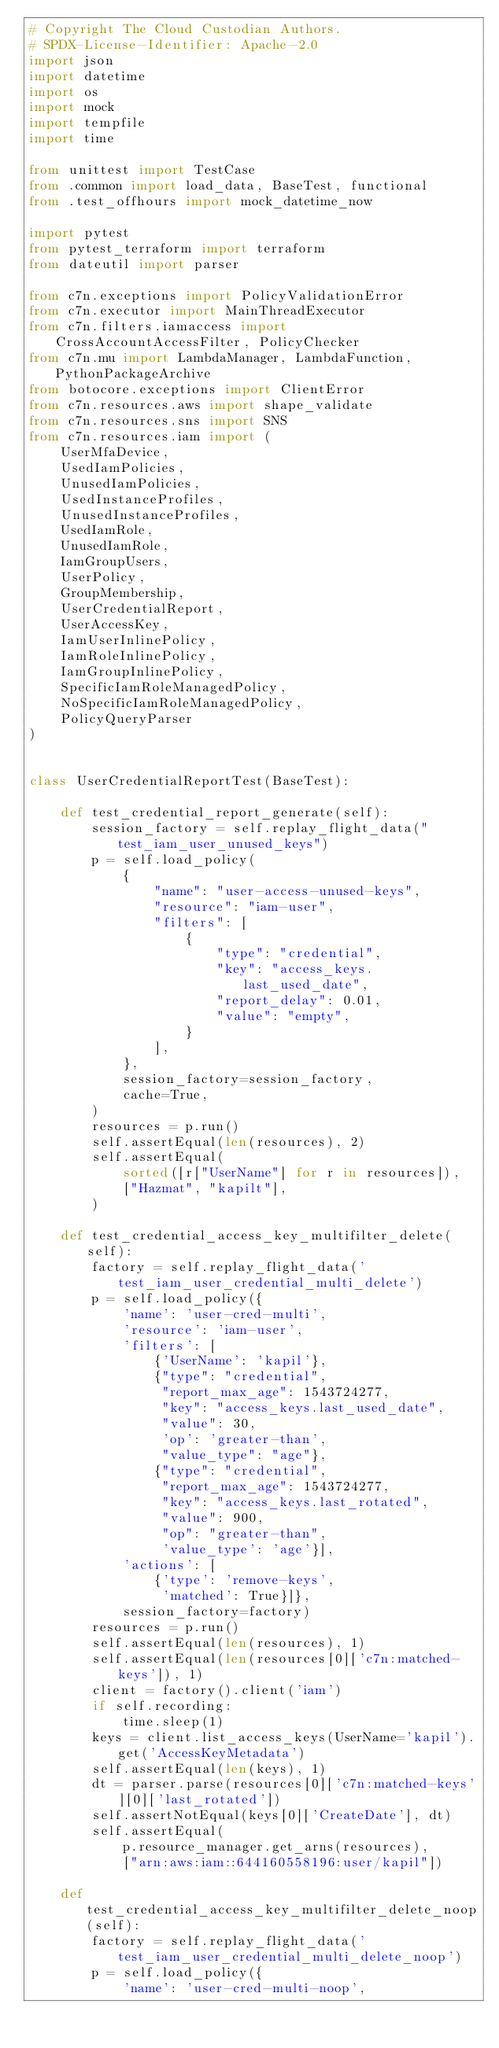Convert code to text. <code><loc_0><loc_0><loc_500><loc_500><_Python_># Copyright The Cloud Custodian Authors.
# SPDX-License-Identifier: Apache-2.0
import json
import datetime
import os
import mock
import tempfile
import time

from unittest import TestCase
from .common import load_data, BaseTest, functional
from .test_offhours import mock_datetime_now

import pytest
from pytest_terraform import terraform
from dateutil import parser

from c7n.exceptions import PolicyValidationError
from c7n.executor import MainThreadExecutor
from c7n.filters.iamaccess import CrossAccountAccessFilter, PolicyChecker
from c7n.mu import LambdaManager, LambdaFunction, PythonPackageArchive
from botocore.exceptions import ClientError
from c7n.resources.aws import shape_validate
from c7n.resources.sns import SNS
from c7n.resources.iam import (
    UserMfaDevice,
    UsedIamPolicies,
    UnusedIamPolicies,
    UsedInstanceProfiles,
    UnusedInstanceProfiles,
    UsedIamRole,
    UnusedIamRole,
    IamGroupUsers,
    UserPolicy,
    GroupMembership,
    UserCredentialReport,
    UserAccessKey,
    IamUserInlinePolicy,
    IamRoleInlinePolicy,
    IamGroupInlinePolicy,
    SpecificIamRoleManagedPolicy,
    NoSpecificIamRoleManagedPolicy,
    PolicyQueryParser
)


class UserCredentialReportTest(BaseTest):

    def test_credential_report_generate(self):
        session_factory = self.replay_flight_data("test_iam_user_unused_keys")
        p = self.load_policy(
            {
                "name": "user-access-unused-keys",
                "resource": "iam-user",
                "filters": [
                    {
                        "type": "credential",
                        "key": "access_keys.last_used_date",
                        "report_delay": 0.01,
                        "value": "empty",
                    }
                ],
            },
            session_factory=session_factory,
            cache=True,
        )
        resources = p.run()
        self.assertEqual(len(resources), 2)
        self.assertEqual(
            sorted([r["UserName"] for r in resources]),
            ["Hazmat", "kapilt"],
        )

    def test_credential_access_key_multifilter_delete(self):
        factory = self.replay_flight_data('test_iam_user_credential_multi_delete')
        p = self.load_policy({
            'name': 'user-cred-multi',
            'resource': 'iam-user',
            'filters': [
                {'UserName': 'kapil'},
                {"type": "credential",
                 "report_max_age": 1543724277,
                 "key": "access_keys.last_used_date",
                 "value": 30,
                 'op': 'greater-than',
                 "value_type": "age"},
                {"type": "credential",
                 "report_max_age": 1543724277,
                 "key": "access_keys.last_rotated",
                 "value": 900,
                 "op": "greater-than",
                 'value_type': 'age'}],
            'actions': [
                {'type': 'remove-keys',
                 'matched': True}]},
            session_factory=factory)
        resources = p.run()
        self.assertEqual(len(resources), 1)
        self.assertEqual(len(resources[0]['c7n:matched-keys']), 1)
        client = factory().client('iam')
        if self.recording:
            time.sleep(1)
        keys = client.list_access_keys(UserName='kapil').get('AccessKeyMetadata')
        self.assertEqual(len(keys), 1)
        dt = parser.parse(resources[0]['c7n:matched-keys'][0]['last_rotated'])
        self.assertNotEqual(keys[0]['CreateDate'], dt)
        self.assertEqual(
            p.resource_manager.get_arns(resources),
            ["arn:aws:iam::644160558196:user/kapil"])

    def test_credential_access_key_multifilter_delete_noop(self):
        factory = self.replay_flight_data('test_iam_user_credential_multi_delete_noop')
        p = self.load_policy({
            'name': 'user-cred-multi-noop',</code> 